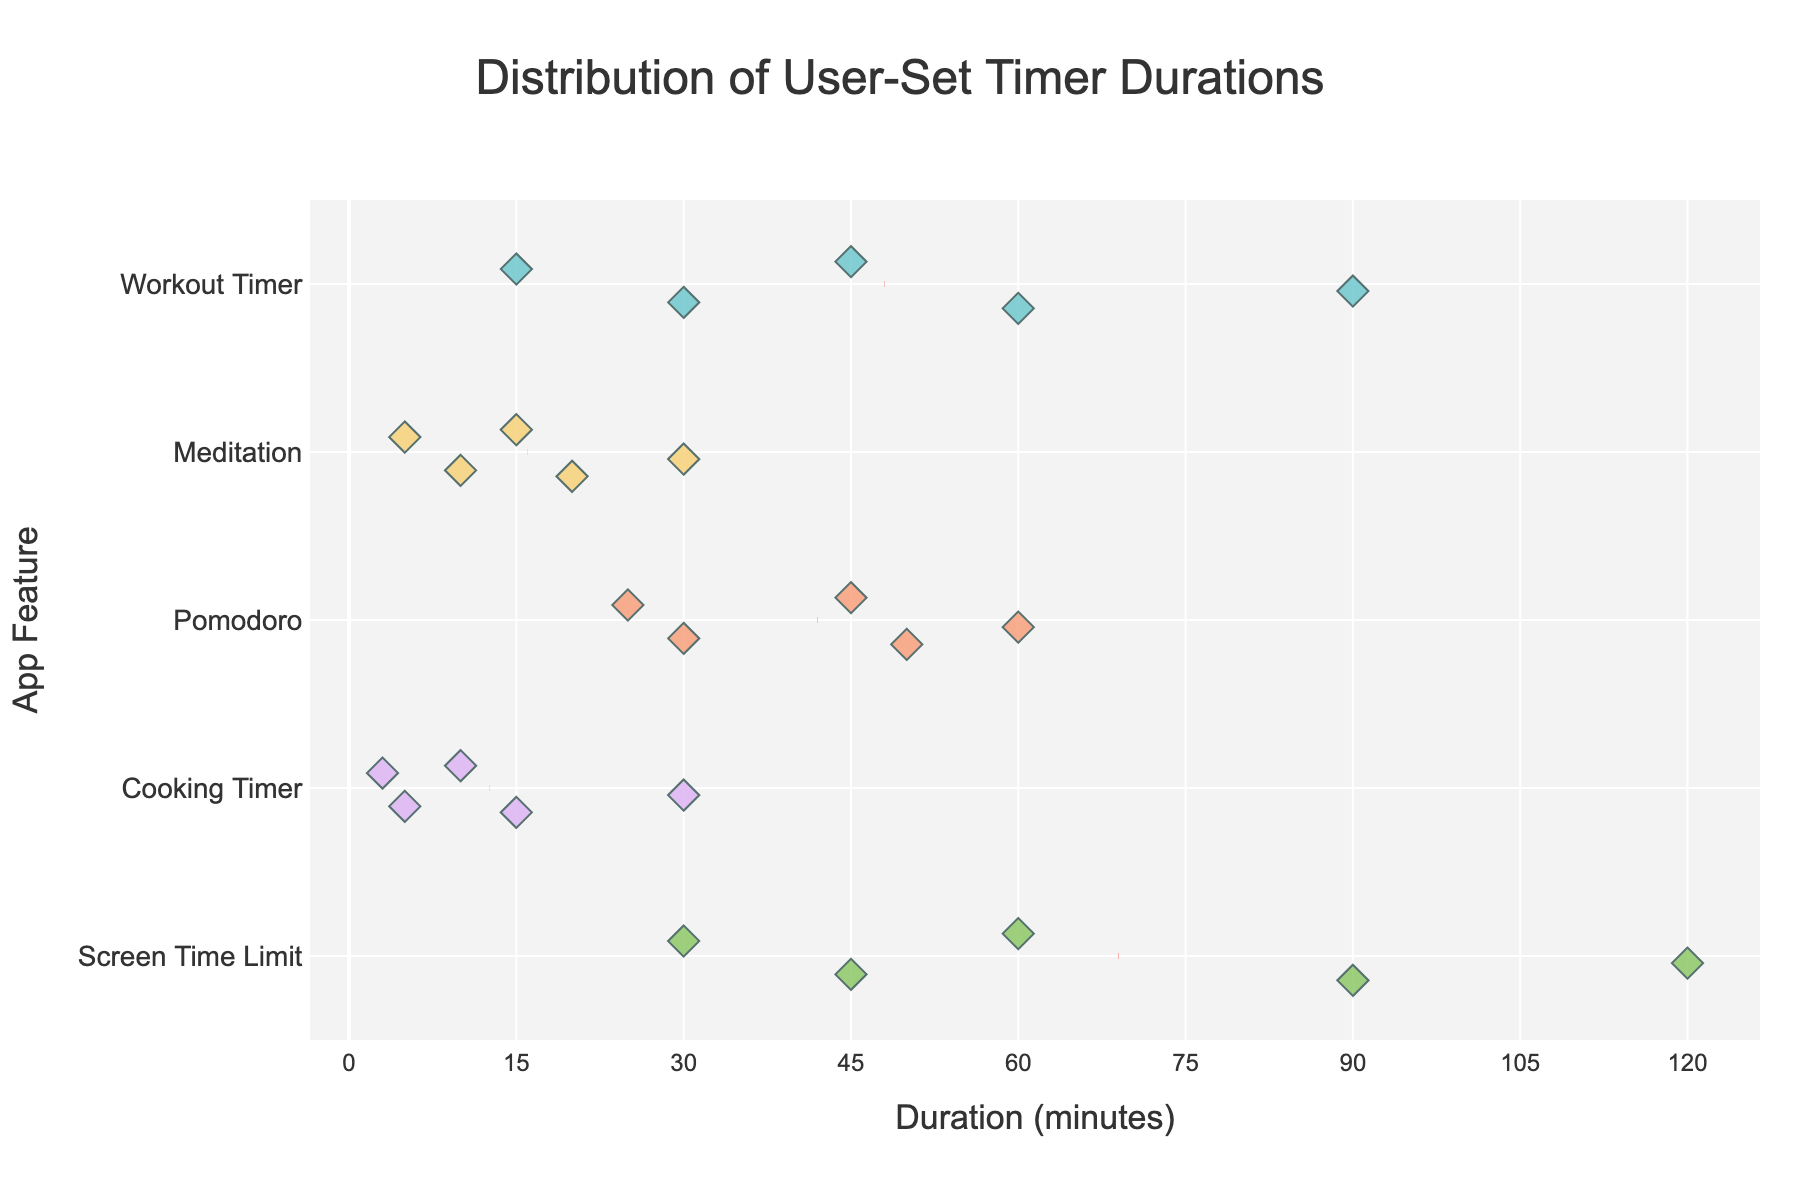What is the title of the figure? The title of the figure is prominently displayed at the top and reads "Distribution of User-Set Timer Durations."
Answer: Distribution of User-Set Timer Durations How many different app features are represented in the figure? The figure shows the unique features by the markers on the y-axis. Each unique label corresponds to a different app feature.
Answer: 5 What is the range of durations for the "Workout Timer" feature? By observing the spread of data points along the x-axis for the "Workout Timer," the minimum and maximum durations can be identified.
Answer: 15 to 90 Which app feature has the widest range of timer durations? To find this, compare the spread of data points along the x-axis for each feature. "Screen Time Limit" has the widest range, from 30 to 120 minutes.
Answer: Screen Time Limit What is the mean duration for the "Cooking Timer" feature? The mean duration for each feature is indicated by a red dashed line. Locate the red line for "Cooking Timer" and read its x-axis position.
Answer: 12.6 How do the median durations of the "Workout Timer" and "Pomodoro" features compare? Identify the median value for each feature by finding the middle data point. Visual inspection shows the "Workout Timer" has a higher median than "Pomodoro."
Answer: Workout Timer > Pomodoro What duration is most frequently set for the "Meditation" feature? Identify the most clustered or frequently occurring duration for "Meditation" by looking for the point density along the x-axis. The most frequent duration observed is 10 minutes.
Answer: 10 minutes Does any feature have all timer durations less than or equal to 30 minutes? If so, which one? Check each feature's duration points to see if all lie at or below 30 minutes. "Meditation" and "Cooking Timer" both fit this criterion.
Answer: Meditation and Cooking Timer For which app feature are the timer durations most closely clustered around the mean? Observe the spread of the data points around the red dashed line (mean) for each feature. "Meditation" has data points closely clustered around its mean.
Answer: Meditation 